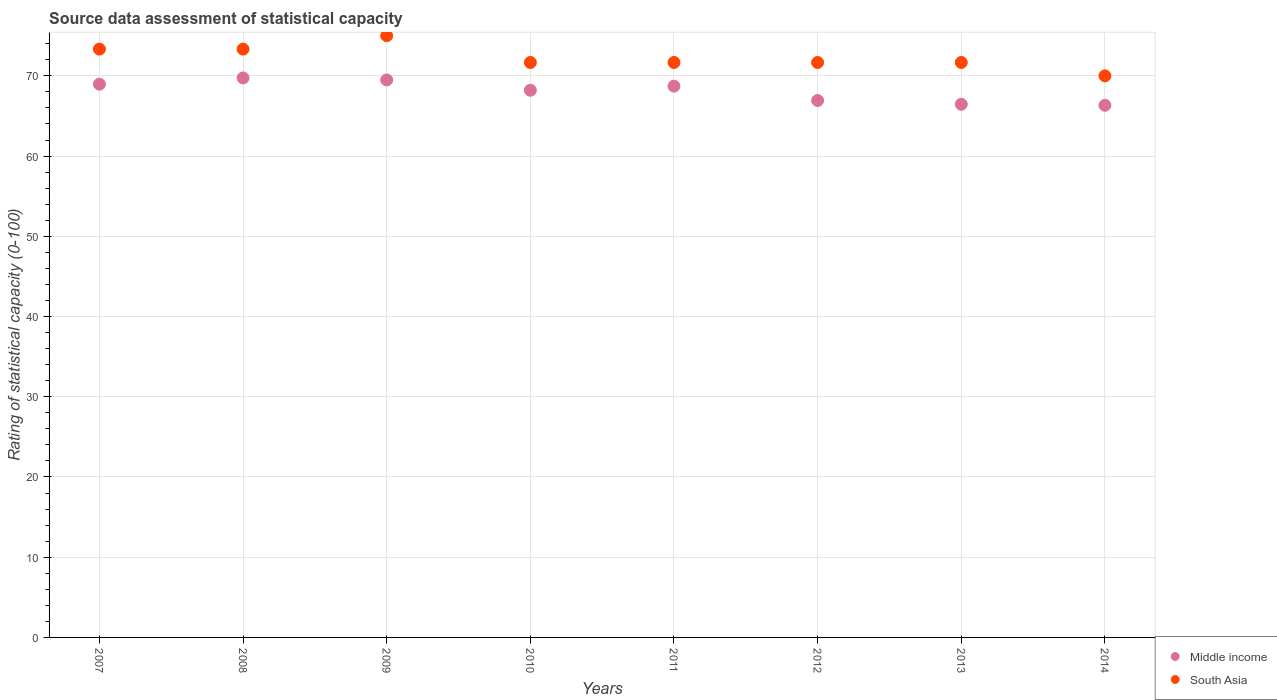How many different coloured dotlines are there?
Keep it short and to the point. 2. Is the number of dotlines equal to the number of legend labels?
Keep it short and to the point. Yes. What is the rating of statistical capacity in South Asia in 2010?
Provide a short and direct response. 71.67. Across all years, what is the maximum rating of statistical capacity in Middle income?
Your answer should be very brief. 69.74. Across all years, what is the minimum rating of statistical capacity in South Asia?
Your response must be concise. 70. In which year was the rating of statistical capacity in South Asia minimum?
Provide a short and direct response. 2014. What is the total rating of statistical capacity in Middle income in the graph?
Provide a short and direct response. 544.82. What is the difference between the rating of statistical capacity in Middle income in 2011 and that in 2014?
Provide a short and direct response. 2.39. What is the difference between the rating of statistical capacity in Middle income in 2013 and the rating of statistical capacity in South Asia in 2010?
Keep it short and to the point. -5.21. What is the average rating of statistical capacity in South Asia per year?
Keep it short and to the point. 72.29. In the year 2014, what is the difference between the rating of statistical capacity in Middle income and rating of statistical capacity in South Asia?
Offer a very short reply. -3.67. In how many years, is the rating of statistical capacity in Middle income greater than 38?
Ensure brevity in your answer.  8. What is the ratio of the rating of statistical capacity in South Asia in 2010 to that in 2014?
Give a very brief answer. 1.02. Is the difference between the rating of statistical capacity in Middle income in 2010 and 2011 greater than the difference between the rating of statistical capacity in South Asia in 2010 and 2011?
Offer a very short reply. No. What is the difference between the highest and the second highest rating of statistical capacity in South Asia?
Keep it short and to the point. 1.67. What is the difference between the highest and the lowest rating of statistical capacity in South Asia?
Offer a terse response. 5. In how many years, is the rating of statistical capacity in Middle income greater than the average rating of statistical capacity in Middle income taken over all years?
Your answer should be compact. 5. Is the rating of statistical capacity in Middle income strictly greater than the rating of statistical capacity in South Asia over the years?
Your answer should be very brief. No. How many years are there in the graph?
Your answer should be very brief. 8. What is the difference between two consecutive major ticks on the Y-axis?
Offer a very short reply. 10. Does the graph contain any zero values?
Offer a terse response. No. Does the graph contain grids?
Provide a succinct answer. Yes. What is the title of the graph?
Provide a succinct answer. Source data assessment of statistical capacity. Does "American Samoa" appear as one of the legend labels in the graph?
Give a very brief answer. No. What is the label or title of the Y-axis?
Provide a succinct answer. Rating of statistical capacity (0-100). What is the Rating of statistical capacity (0-100) of Middle income in 2007?
Make the answer very short. 68.96. What is the Rating of statistical capacity (0-100) in South Asia in 2007?
Make the answer very short. 73.33. What is the Rating of statistical capacity (0-100) of Middle income in 2008?
Offer a terse response. 69.74. What is the Rating of statistical capacity (0-100) of South Asia in 2008?
Make the answer very short. 73.33. What is the Rating of statistical capacity (0-100) in Middle income in 2009?
Offer a terse response. 69.49. What is the Rating of statistical capacity (0-100) of Middle income in 2010?
Offer a terse response. 68.21. What is the Rating of statistical capacity (0-100) in South Asia in 2010?
Offer a very short reply. 71.67. What is the Rating of statistical capacity (0-100) in Middle income in 2011?
Make the answer very short. 68.72. What is the Rating of statistical capacity (0-100) of South Asia in 2011?
Give a very brief answer. 71.67. What is the Rating of statistical capacity (0-100) of Middle income in 2012?
Offer a very short reply. 66.92. What is the Rating of statistical capacity (0-100) of South Asia in 2012?
Your answer should be very brief. 71.67. What is the Rating of statistical capacity (0-100) of Middle income in 2013?
Keep it short and to the point. 66.46. What is the Rating of statistical capacity (0-100) of South Asia in 2013?
Ensure brevity in your answer.  71.67. What is the Rating of statistical capacity (0-100) of Middle income in 2014?
Your response must be concise. 66.33. Across all years, what is the maximum Rating of statistical capacity (0-100) of Middle income?
Make the answer very short. 69.74. Across all years, what is the maximum Rating of statistical capacity (0-100) in South Asia?
Give a very brief answer. 75. Across all years, what is the minimum Rating of statistical capacity (0-100) of Middle income?
Give a very brief answer. 66.33. Across all years, what is the minimum Rating of statistical capacity (0-100) of South Asia?
Offer a terse response. 70. What is the total Rating of statistical capacity (0-100) of Middle income in the graph?
Offer a very short reply. 544.82. What is the total Rating of statistical capacity (0-100) of South Asia in the graph?
Offer a terse response. 578.33. What is the difference between the Rating of statistical capacity (0-100) of Middle income in 2007 and that in 2008?
Provide a short and direct response. -0.78. What is the difference between the Rating of statistical capacity (0-100) in Middle income in 2007 and that in 2009?
Provide a short and direct response. -0.53. What is the difference between the Rating of statistical capacity (0-100) in South Asia in 2007 and that in 2009?
Keep it short and to the point. -1.67. What is the difference between the Rating of statistical capacity (0-100) in Middle income in 2007 and that in 2010?
Offer a very short reply. 0.76. What is the difference between the Rating of statistical capacity (0-100) of Middle income in 2007 and that in 2011?
Provide a succinct answer. 0.24. What is the difference between the Rating of statistical capacity (0-100) in Middle income in 2007 and that in 2012?
Ensure brevity in your answer.  2.04. What is the difference between the Rating of statistical capacity (0-100) of Middle income in 2007 and that in 2013?
Your response must be concise. 2.51. What is the difference between the Rating of statistical capacity (0-100) of Middle income in 2007 and that in 2014?
Offer a very short reply. 2.63. What is the difference between the Rating of statistical capacity (0-100) of Middle income in 2008 and that in 2009?
Give a very brief answer. 0.25. What is the difference between the Rating of statistical capacity (0-100) in South Asia in 2008 and that in 2009?
Give a very brief answer. -1.67. What is the difference between the Rating of statistical capacity (0-100) in Middle income in 2008 and that in 2010?
Keep it short and to the point. 1.54. What is the difference between the Rating of statistical capacity (0-100) in South Asia in 2008 and that in 2010?
Your response must be concise. 1.67. What is the difference between the Rating of statistical capacity (0-100) in Middle income in 2008 and that in 2011?
Your answer should be compact. 1.02. What is the difference between the Rating of statistical capacity (0-100) in South Asia in 2008 and that in 2011?
Offer a very short reply. 1.67. What is the difference between the Rating of statistical capacity (0-100) of Middle income in 2008 and that in 2012?
Keep it short and to the point. 2.82. What is the difference between the Rating of statistical capacity (0-100) in Middle income in 2008 and that in 2013?
Offer a very short reply. 3.28. What is the difference between the Rating of statistical capacity (0-100) in South Asia in 2008 and that in 2013?
Ensure brevity in your answer.  1.67. What is the difference between the Rating of statistical capacity (0-100) of Middle income in 2008 and that in 2014?
Ensure brevity in your answer.  3.41. What is the difference between the Rating of statistical capacity (0-100) of South Asia in 2008 and that in 2014?
Make the answer very short. 3.33. What is the difference between the Rating of statistical capacity (0-100) of Middle income in 2009 and that in 2010?
Give a very brief answer. 1.28. What is the difference between the Rating of statistical capacity (0-100) in Middle income in 2009 and that in 2011?
Keep it short and to the point. 0.77. What is the difference between the Rating of statistical capacity (0-100) of Middle income in 2009 and that in 2012?
Ensure brevity in your answer.  2.56. What is the difference between the Rating of statistical capacity (0-100) in Middle income in 2009 and that in 2013?
Make the answer very short. 3.03. What is the difference between the Rating of statistical capacity (0-100) of Middle income in 2009 and that in 2014?
Provide a short and direct response. 3.16. What is the difference between the Rating of statistical capacity (0-100) of Middle income in 2010 and that in 2011?
Ensure brevity in your answer.  -0.51. What is the difference between the Rating of statistical capacity (0-100) of South Asia in 2010 and that in 2011?
Ensure brevity in your answer.  0. What is the difference between the Rating of statistical capacity (0-100) of Middle income in 2010 and that in 2012?
Keep it short and to the point. 1.28. What is the difference between the Rating of statistical capacity (0-100) of South Asia in 2010 and that in 2012?
Provide a short and direct response. 0. What is the difference between the Rating of statistical capacity (0-100) in Middle income in 2010 and that in 2013?
Offer a very short reply. 1.75. What is the difference between the Rating of statistical capacity (0-100) of Middle income in 2010 and that in 2014?
Ensure brevity in your answer.  1.88. What is the difference between the Rating of statistical capacity (0-100) in Middle income in 2011 and that in 2012?
Offer a very short reply. 1.79. What is the difference between the Rating of statistical capacity (0-100) of South Asia in 2011 and that in 2012?
Make the answer very short. 0. What is the difference between the Rating of statistical capacity (0-100) in Middle income in 2011 and that in 2013?
Ensure brevity in your answer.  2.26. What is the difference between the Rating of statistical capacity (0-100) of South Asia in 2011 and that in 2013?
Offer a very short reply. 0. What is the difference between the Rating of statistical capacity (0-100) of Middle income in 2011 and that in 2014?
Your answer should be compact. 2.39. What is the difference between the Rating of statistical capacity (0-100) in Middle income in 2012 and that in 2013?
Your answer should be compact. 0.47. What is the difference between the Rating of statistical capacity (0-100) of Middle income in 2012 and that in 2014?
Provide a succinct answer. 0.59. What is the difference between the Rating of statistical capacity (0-100) of South Asia in 2012 and that in 2014?
Provide a short and direct response. 1.67. What is the difference between the Rating of statistical capacity (0-100) in Middle income in 2013 and that in 2014?
Keep it short and to the point. 0.13. What is the difference between the Rating of statistical capacity (0-100) of South Asia in 2013 and that in 2014?
Give a very brief answer. 1.67. What is the difference between the Rating of statistical capacity (0-100) in Middle income in 2007 and the Rating of statistical capacity (0-100) in South Asia in 2008?
Give a very brief answer. -4.37. What is the difference between the Rating of statistical capacity (0-100) of Middle income in 2007 and the Rating of statistical capacity (0-100) of South Asia in 2009?
Your answer should be compact. -6.04. What is the difference between the Rating of statistical capacity (0-100) in Middle income in 2007 and the Rating of statistical capacity (0-100) in South Asia in 2010?
Your answer should be compact. -2.71. What is the difference between the Rating of statistical capacity (0-100) of Middle income in 2007 and the Rating of statistical capacity (0-100) of South Asia in 2011?
Your response must be concise. -2.71. What is the difference between the Rating of statistical capacity (0-100) in Middle income in 2007 and the Rating of statistical capacity (0-100) in South Asia in 2012?
Offer a very short reply. -2.71. What is the difference between the Rating of statistical capacity (0-100) in Middle income in 2007 and the Rating of statistical capacity (0-100) in South Asia in 2013?
Your answer should be compact. -2.71. What is the difference between the Rating of statistical capacity (0-100) in Middle income in 2007 and the Rating of statistical capacity (0-100) in South Asia in 2014?
Give a very brief answer. -1.04. What is the difference between the Rating of statistical capacity (0-100) in Middle income in 2008 and the Rating of statistical capacity (0-100) in South Asia in 2009?
Ensure brevity in your answer.  -5.26. What is the difference between the Rating of statistical capacity (0-100) in Middle income in 2008 and the Rating of statistical capacity (0-100) in South Asia in 2010?
Offer a very short reply. -1.93. What is the difference between the Rating of statistical capacity (0-100) in Middle income in 2008 and the Rating of statistical capacity (0-100) in South Asia in 2011?
Give a very brief answer. -1.93. What is the difference between the Rating of statistical capacity (0-100) of Middle income in 2008 and the Rating of statistical capacity (0-100) of South Asia in 2012?
Your response must be concise. -1.93. What is the difference between the Rating of statistical capacity (0-100) of Middle income in 2008 and the Rating of statistical capacity (0-100) of South Asia in 2013?
Your response must be concise. -1.93. What is the difference between the Rating of statistical capacity (0-100) in Middle income in 2008 and the Rating of statistical capacity (0-100) in South Asia in 2014?
Your answer should be compact. -0.26. What is the difference between the Rating of statistical capacity (0-100) in Middle income in 2009 and the Rating of statistical capacity (0-100) in South Asia in 2010?
Offer a very short reply. -2.18. What is the difference between the Rating of statistical capacity (0-100) of Middle income in 2009 and the Rating of statistical capacity (0-100) of South Asia in 2011?
Give a very brief answer. -2.18. What is the difference between the Rating of statistical capacity (0-100) in Middle income in 2009 and the Rating of statistical capacity (0-100) in South Asia in 2012?
Keep it short and to the point. -2.18. What is the difference between the Rating of statistical capacity (0-100) in Middle income in 2009 and the Rating of statistical capacity (0-100) in South Asia in 2013?
Provide a short and direct response. -2.18. What is the difference between the Rating of statistical capacity (0-100) of Middle income in 2009 and the Rating of statistical capacity (0-100) of South Asia in 2014?
Provide a succinct answer. -0.51. What is the difference between the Rating of statistical capacity (0-100) in Middle income in 2010 and the Rating of statistical capacity (0-100) in South Asia in 2011?
Make the answer very short. -3.46. What is the difference between the Rating of statistical capacity (0-100) in Middle income in 2010 and the Rating of statistical capacity (0-100) in South Asia in 2012?
Provide a short and direct response. -3.46. What is the difference between the Rating of statistical capacity (0-100) of Middle income in 2010 and the Rating of statistical capacity (0-100) of South Asia in 2013?
Your response must be concise. -3.46. What is the difference between the Rating of statistical capacity (0-100) in Middle income in 2010 and the Rating of statistical capacity (0-100) in South Asia in 2014?
Your response must be concise. -1.79. What is the difference between the Rating of statistical capacity (0-100) of Middle income in 2011 and the Rating of statistical capacity (0-100) of South Asia in 2012?
Provide a succinct answer. -2.95. What is the difference between the Rating of statistical capacity (0-100) in Middle income in 2011 and the Rating of statistical capacity (0-100) in South Asia in 2013?
Offer a very short reply. -2.95. What is the difference between the Rating of statistical capacity (0-100) in Middle income in 2011 and the Rating of statistical capacity (0-100) in South Asia in 2014?
Offer a terse response. -1.28. What is the difference between the Rating of statistical capacity (0-100) in Middle income in 2012 and the Rating of statistical capacity (0-100) in South Asia in 2013?
Provide a succinct answer. -4.74. What is the difference between the Rating of statistical capacity (0-100) of Middle income in 2012 and the Rating of statistical capacity (0-100) of South Asia in 2014?
Offer a terse response. -3.08. What is the difference between the Rating of statistical capacity (0-100) of Middle income in 2013 and the Rating of statistical capacity (0-100) of South Asia in 2014?
Your answer should be very brief. -3.54. What is the average Rating of statistical capacity (0-100) of Middle income per year?
Offer a terse response. 68.1. What is the average Rating of statistical capacity (0-100) of South Asia per year?
Provide a short and direct response. 72.29. In the year 2007, what is the difference between the Rating of statistical capacity (0-100) in Middle income and Rating of statistical capacity (0-100) in South Asia?
Provide a short and direct response. -4.37. In the year 2008, what is the difference between the Rating of statistical capacity (0-100) in Middle income and Rating of statistical capacity (0-100) in South Asia?
Provide a succinct answer. -3.59. In the year 2009, what is the difference between the Rating of statistical capacity (0-100) of Middle income and Rating of statistical capacity (0-100) of South Asia?
Give a very brief answer. -5.51. In the year 2010, what is the difference between the Rating of statistical capacity (0-100) in Middle income and Rating of statistical capacity (0-100) in South Asia?
Provide a succinct answer. -3.46. In the year 2011, what is the difference between the Rating of statistical capacity (0-100) in Middle income and Rating of statistical capacity (0-100) in South Asia?
Make the answer very short. -2.95. In the year 2012, what is the difference between the Rating of statistical capacity (0-100) of Middle income and Rating of statistical capacity (0-100) of South Asia?
Offer a very short reply. -4.74. In the year 2013, what is the difference between the Rating of statistical capacity (0-100) in Middle income and Rating of statistical capacity (0-100) in South Asia?
Give a very brief answer. -5.21. In the year 2014, what is the difference between the Rating of statistical capacity (0-100) in Middle income and Rating of statistical capacity (0-100) in South Asia?
Your answer should be compact. -3.67. What is the ratio of the Rating of statistical capacity (0-100) in Middle income in 2007 to that in 2008?
Keep it short and to the point. 0.99. What is the ratio of the Rating of statistical capacity (0-100) in South Asia in 2007 to that in 2009?
Provide a succinct answer. 0.98. What is the ratio of the Rating of statistical capacity (0-100) in Middle income in 2007 to that in 2010?
Give a very brief answer. 1.01. What is the ratio of the Rating of statistical capacity (0-100) of South Asia in 2007 to that in 2010?
Provide a succinct answer. 1.02. What is the ratio of the Rating of statistical capacity (0-100) in Middle income in 2007 to that in 2011?
Offer a terse response. 1. What is the ratio of the Rating of statistical capacity (0-100) in South Asia in 2007 to that in 2011?
Give a very brief answer. 1.02. What is the ratio of the Rating of statistical capacity (0-100) in Middle income in 2007 to that in 2012?
Ensure brevity in your answer.  1.03. What is the ratio of the Rating of statistical capacity (0-100) of South Asia in 2007 to that in 2012?
Provide a short and direct response. 1.02. What is the ratio of the Rating of statistical capacity (0-100) of Middle income in 2007 to that in 2013?
Provide a succinct answer. 1.04. What is the ratio of the Rating of statistical capacity (0-100) in South Asia in 2007 to that in 2013?
Offer a very short reply. 1.02. What is the ratio of the Rating of statistical capacity (0-100) of Middle income in 2007 to that in 2014?
Keep it short and to the point. 1.04. What is the ratio of the Rating of statistical capacity (0-100) of South Asia in 2007 to that in 2014?
Ensure brevity in your answer.  1.05. What is the ratio of the Rating of statistical capacity (0-100) of South Asia in 2008 to that in 2009?
Offer a very short reply. 0.98. What is the ratio of the Rating of statistical capacity (0-100) of Middle income in 2008 to that in 2010?
Your response must be concise. 1.02. What is the ratio of the Rating of statistical capacity (0-100) in South Asia in 2008 to that in 2010?
Make the answer very short. 1.02. What is the ratio of the Rating of statistical capacity (0-100) of Middle income in 2008 to that in 2011?
Your response must be concise. 1.01. What is the ratio of the Rating of statistical capacity (0-100) in South Asia in 2008 to that in 2011?
Provide a succinct answer. 1.02. What is the ratio of the Rating of statistical capacity (0-100) in Middle income in 2008 to that in 2012?
Give a very brief answer. 1.04. What is the ratio of the Rating of statistical capacity (0-100) of South Asia in 2008 to that in 2012?
Offer a very short reply. 1.02. What is the ratio of the Rating of statistical capacity (0-100) of Middle income in 2008 to that in 2013?
Make the answer very short. 1.05. What is the ratio of the Rating of statistical capacity (0-100) of South Asia in 2008 to that in 2013?
Your answer should be very brief. 1.02. What is the ratio of the Rating of statistical capacity (0-100) of Middle income in 2008 to that in 2014?
Your answer should be very brief. 1.05. What is the ratio of the Rating of statistical capacity (0-100) in South Asia in 2008 to that in 2014?
Ensure brevity in your answer.  1.05. What is the ratio of the Rating of statistical capacity (0-100) of Middle income in 2009 to that in 2010?
Give a very brief answer. 1.02. What is the ratio of the Rating of statistical capacity (0-100) of South Asia in 2009 to that in 2010?
Make the answer very short. 1.05. What is the ratio of the Rating of statistical capacity (0-100) of Middle income in 2009 to that in 2011?
Your response must be concise. 1.01. What is the ratio of the Rating of statistical capacity (0-100) in South Asia in 2009 to that in 2011?
Provide a short and direct response. 1.05. What is the ratio of the Rating of statistical capacity (0-100) of Middle income in 2009 to that in 2012?
Offer a very short reply. 1.04. What is the ratio of the Rating of statistical capacity (0-100) in South Asia in 2009 to that in 2012?
Your answer should be compact. 1.05. What is the ratio of the Rating of statistical capacity (0-100) in Middle income in 2009 to that in 2013?
Your answer should be very brief. 1.05. What is the ratio of the Rating of statistical capacity (0-100) of South Asia in 2009 to that in 2013?
Your answer should be compact. 1.05. What is the ratio of the Rating of statistical capacity (0-100) in Middle income in 2009 to that in 2014?
Ensure brevity in your answer.  1.05. What is the ratio of the Rating of statistical capacity (0-100) of South Asia in 2009 to that in 2014?
Ensure brevity in your answer.  1.07. What is the ratio of the Rating of statistical capacity (0-100) of South Asia in 2010 to that in 2011?
Your answer should be very brief. 1. What is the ratio of the Rating of statistical capacity (0-100) in Middle income in 2010 to that in 2012?
Offer a very short reply. 1.02. What is the ratio of the Rating of statistical capacity (0-100) of South Asia in 2010 to that in 2012?
Provide a succinct answer. 1. What is the ratio of the Rating of statistical capacity (0-100) in Middle income in 2010 to that in 2013?
Your answer should be very brief. 1.03. What is the ratio of the Rating of statistical capacity (0-100) of Middle income in 2010 to that in 2014?
Ensure brevity in your answer.  1.03. What is the ratio of the Rating of statistical capacity (0-100) of South Asia in 2010 to that in 2014?
Offer a very short reply. 1.02. What is the ratio of the Rating of statistical capacity (0-100) of Middle income in 2011 to that in 2012?
Provide a succinct answer. 1.03. What is the ratio of the Rating of statistical capacity (0-100) of South Asia in 2011 to that in 2012?
Ensure brevity in your answer.  1. What is the ratio of the Rating of statistical capacity (0-100) of Middle income in 2011 to that in 2013?
Provide a succinct answer. 1.03. What is the ratio of the Rating of statistical capacity (0-100) in South Asia in 2011 to that in 2013?
Keep it short and to the point. 1. What is the ratio of the Rating of statistical capacity (0-100) in Middle income in 2011 to that in 2014?
Make the answer very short. 1.04. What is the ratio of the Rating of statistical capacity (0-100) in South Asia in 2011 to that in 2014?
Keep it short and to the point. 1.02. What is the ratio of the Rating of statistical capacity (0-100) of Middle income in 2012 to that in 2013?
Your response must be concise. 1.01. What is the ratio of the Rating of statistical capacity (0-100) in South Asia in 2012 to that in 2013?
Your answer should be very brief. 1. What is the ratio of the Rating of statistical capacity (0-100) of Middle income in 2012 to that in 2014?
Your response must be concise. 1.01. What is the ratio of the Rating of statistical capacity (0-100) in South Asia in 2012 to that in 2014?
Ensure brevity in your answer.  1.02. What is the ratio of the Rating of statistical capacity (0-100) of Middle income in 2013 to that in 2014?
Your answer should be compact. 1. What is the ratio of the Rating of statistical capacity (0-100) in South Asia in 2013 to that in 2014?
Provide a short and direct response. 1.02. What is the difference between the highest and the second highest Rating of statistical capacity (0-100) of Middle income?
Your answer should be very brief. 0.25. What is the difference between the highest and the second highest Rating of statistical capacity (0-100) in South Asia?
Ensure brevity in your answer.  1.67. What is the difference between the highest and the lowest Rating of statistical capacity (0-100) of Middle income?
Offer a very short reply. 3.41. What is the difference between the highest and the lowest Rating of statistical capacity (0-100) of South Asia?
Ensure brevity in your answer.  5. 